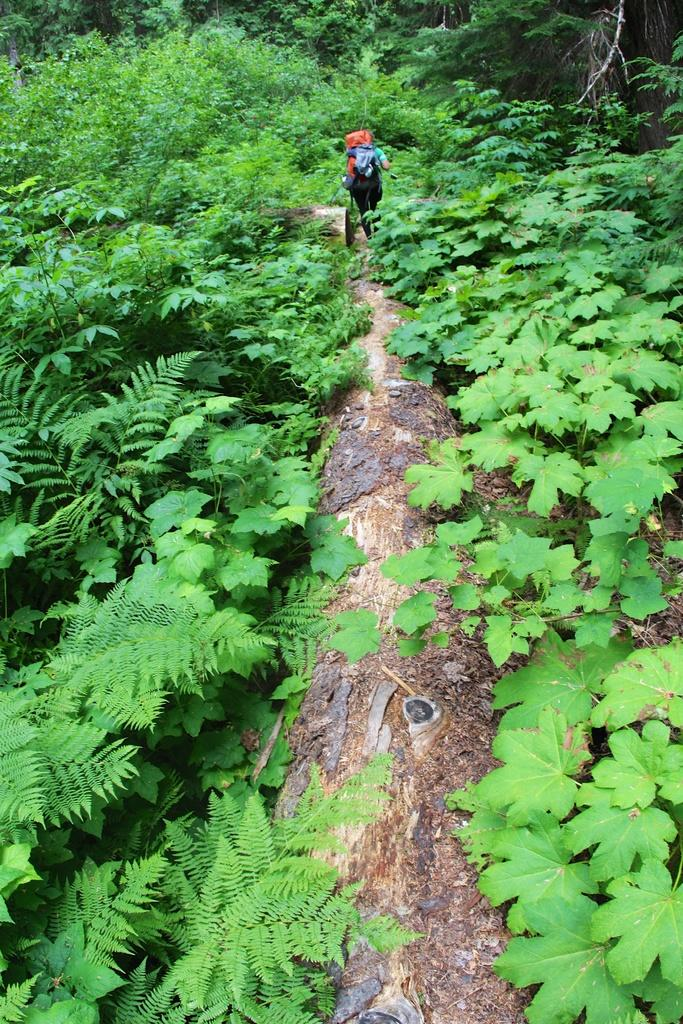What type of living organisms can be seen in the image? Plants can be seen in the image. Can you describe the person in the image? There is a person standing in the image. What can be seen in the background of the image? There are trees in the background of the image. What type of button can be seen on the bed in the image? There is no bed or button present in the image; it features plants and a person standing. 